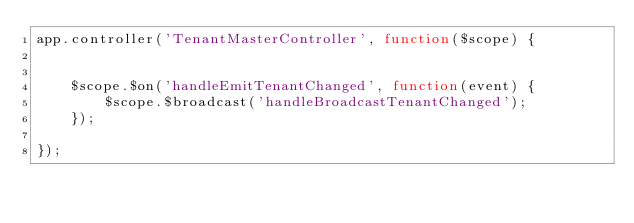Convert code to text. <code><loc_0><loc_0><loc_500><loc_500><_JavaScript_>app.controller('TenantMasterController', function($scope) {


	$scope.$on('handleEmitTenantChanged', function(event) {
		$scope.$broadcast('handleBroadcastTenantChanged');
	});

});
</code> 